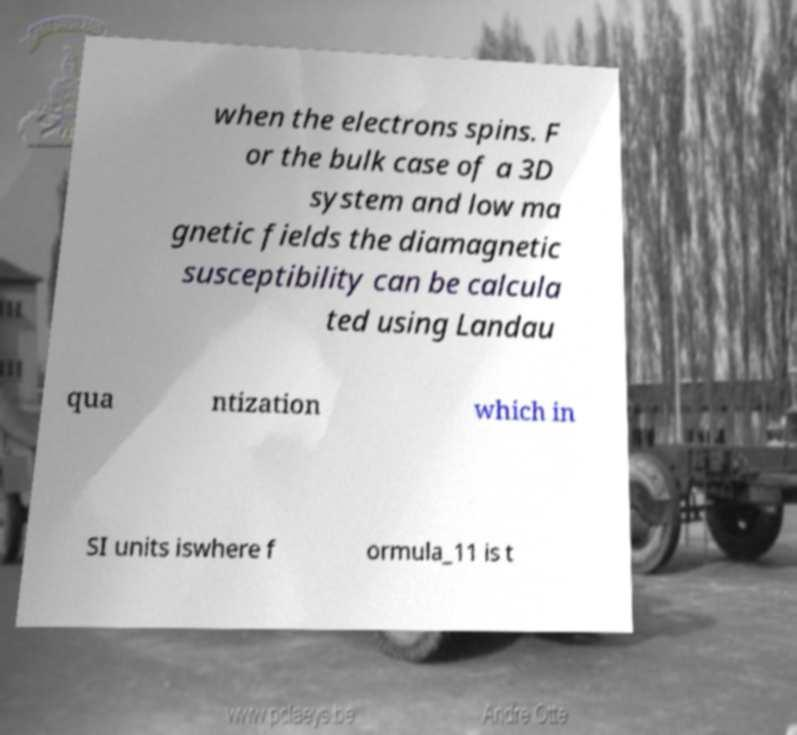There's text embedded in this image that I need extracted. Can you transcribe it verbatim? when the electrons spins. F or the bulk case of a 3D system and low ma gnetic fields the diamagnetic susceptibility can be calcula ted using Landau qua ntization which in SI units iswhere f ormula_11 is t 